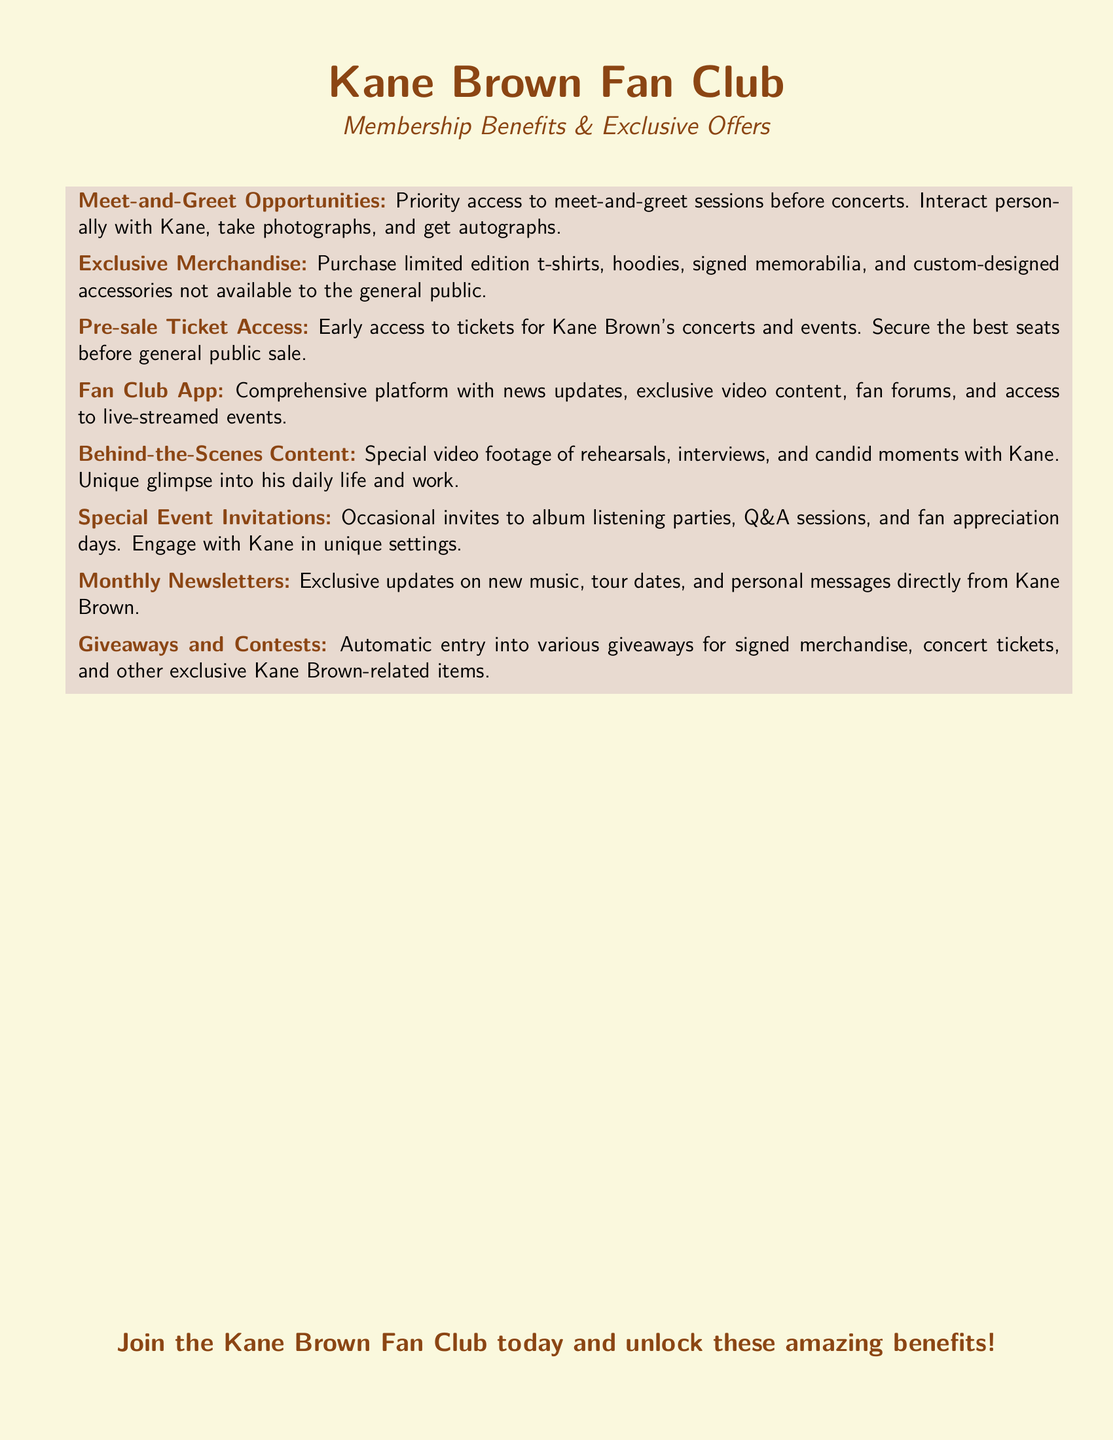What is the priority benefit of the fan club? The benefit provides priority access to meet-and-greet sessions with Kane Brown before concerts.
Answer: Meet-and-Greet Opportunities What type of merchandise can fan club members purchase? Members can purchase limited edition t-shirts, hoodies, signed memorabilia, and custom-designed accessories.
Answer: Exclusive Merchandise What early access do fan club members receive? Members have early access to tickets for Kane Brown's concerts and events.
Answer: Pre-sale Ticket Access What kind of content is available on the Fan Club App? The app features news updates, exclusive video content, fan forums, and access to live-streamed events.
Answer: Fan Club App How often do fans receive newsletters? Fans receive newsletters monthly with exclusive updates.
Answer: Monthly Newsletters What kind of events do special invitations cover? Invitations may cover album listening parties, Q&A sessions, and fan appreciation days.
Answer: Special Event Invitations What is the benefit related to giveaways? The benefit includes automatic entry into various giveaways for signed merchandise and concert tickets.
Answer: Giveaways and Contests What type of content offers a glimpse into Kane's daily life? The behind-the-scenes content includes special video footage of rehearsals, interviews, and candid moments.
Answer: Behind-the-Scenes Content 